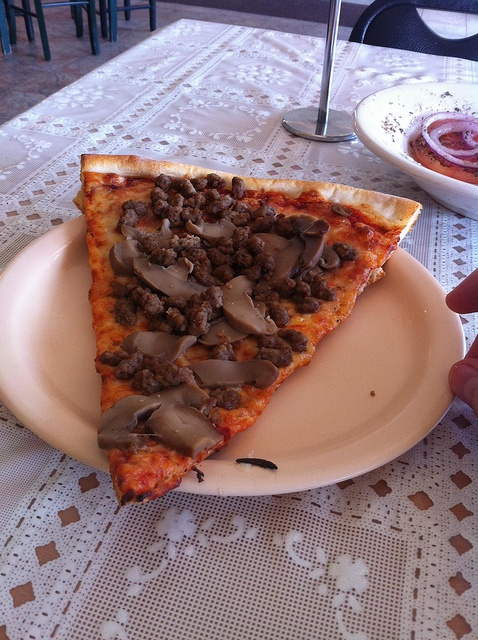Describe the objects in this image and their specific colors. I can see dining table in darkgray, lavender, maroon, darkblue, and gray tones, pizza in darkblue, maroon, black, and brown tones, bowl in darkblue, white, darkgray, brown, and gray tones, chair in darkblue, navy, black, and lavender tones, and people in darkblue, maroon, brown, and purple tones in this image. 